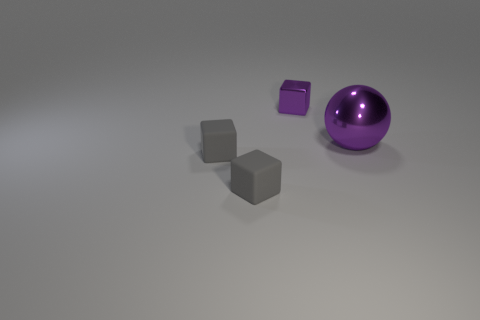Add 3 cubes. How many objects exist? 7 Subtract all blocks. How many objects are left? 1 Subtract all tiny red spheres. Subtract all small gray things. How many objects are left? 2 Add 4 gray objects. How many gray objects are left? 6 Add 3 tiny blocks. How many tiny blocks exist? 6 Subtract 0 yellow cubes. How many objects are left? 4 